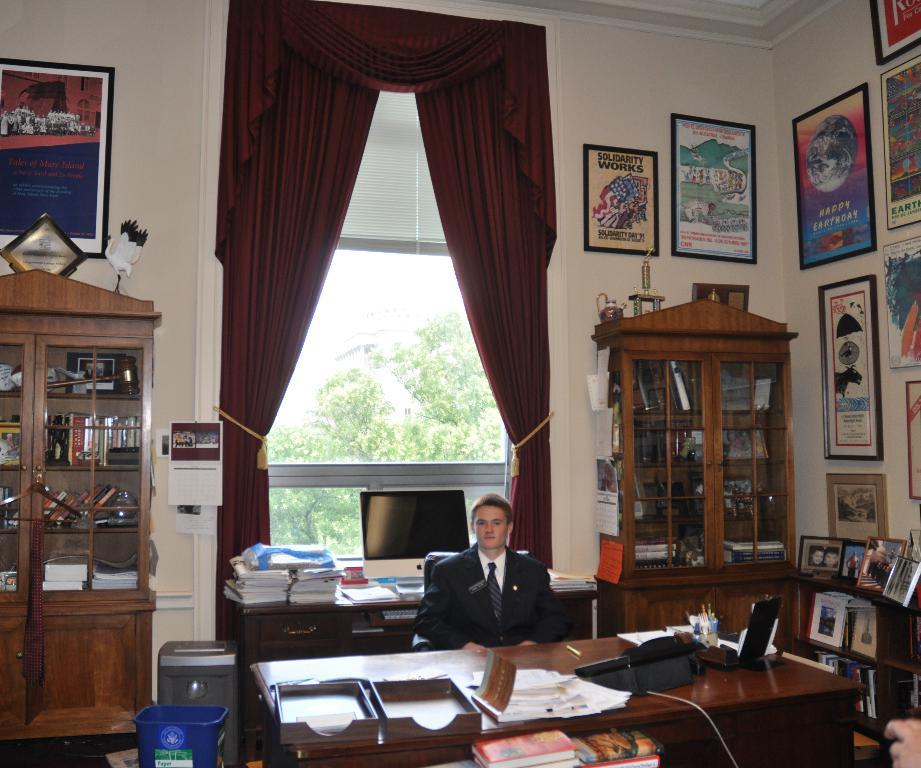Does solidarty work?
Your response must be concise. Yes. 